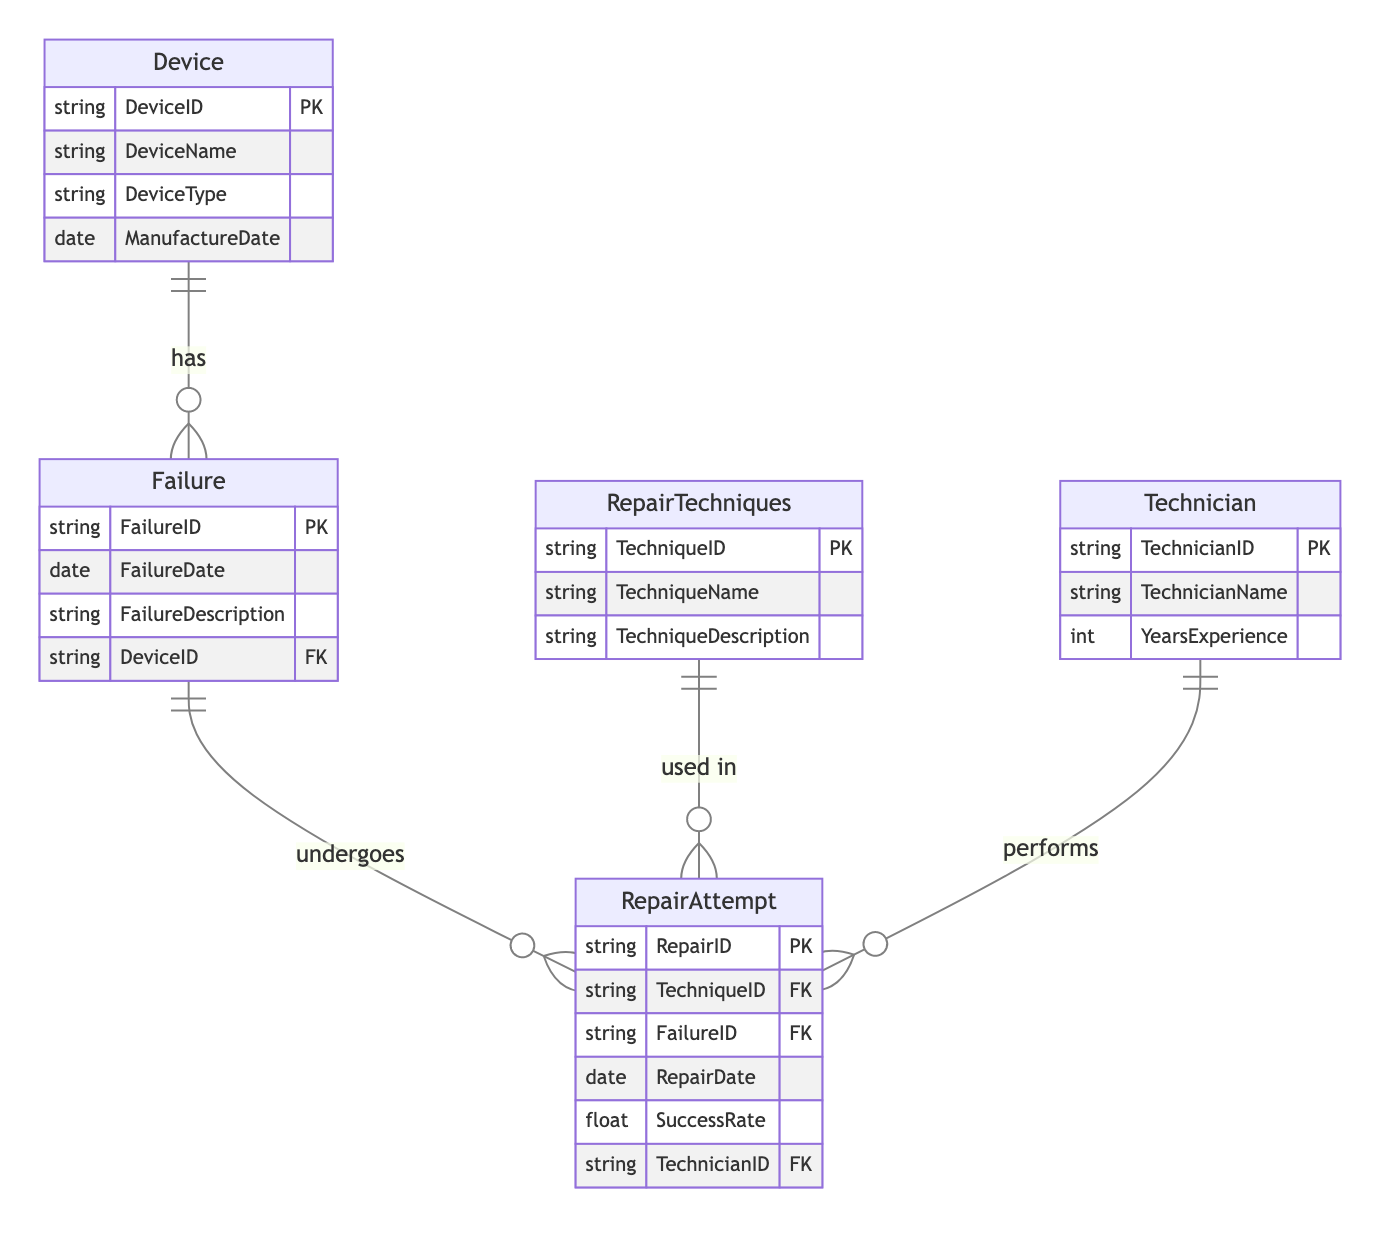What is the primary key of the Device entity? The primary key for the Device entity is DeviceID, as it uniquely identifies each device in the database.
Answer: DeviceID How many failure types are associated with a single device? The relationship between the Device and Failure entities is "one-to-many," meaning one device can have multiple types of failures recorded.
Answer: Many What relationship type exists between RepairAttempt and Technician? The relationship between RepairAttempt and Technician is "many-to-one," indicating that multiple repair attempts can be linked to a single technician.
Answer: Many-to-One Which entity does the RepairTechniques entity relate to? The RepairTechniques entity relates to the RepairAttempt entity, indicating that each repair attempt can utilize specific repair techniques.
Answer: RepairAttempt What attribute connects Failure and RepairAttempt entities? The connecting attribute between Failure and RepairAttempt entities is FailureID, as it serves as the foreign key in the RepairAttempt entity referencing the Failure entity.
Answer: FailureID How many primary keys are present in the diagram? There are five primary keys total, one for each of the following entities: Device, Failure, RepairTechniques, RepairAttempt, and Technician.
Answer: Five What describes the relationship between Device and Failure? The relationship between Device and Failure is described as "one-to-many," meaning one device can experience several different failures.
Answer: One-to-Many What is the foreign key in the RepairAttempt entity that links it to the Technician entity? The linking foreign key in the RepairAttempt entity to the Technician entity is TechnicianID.
Answer: TechnicianID Which entity has the SuccessRate attribute? The SuccessRate attribute is found in the RepairAttempt entity, representing the success of repair attempts linked to specific failures.
Answer: RepairAttempt 